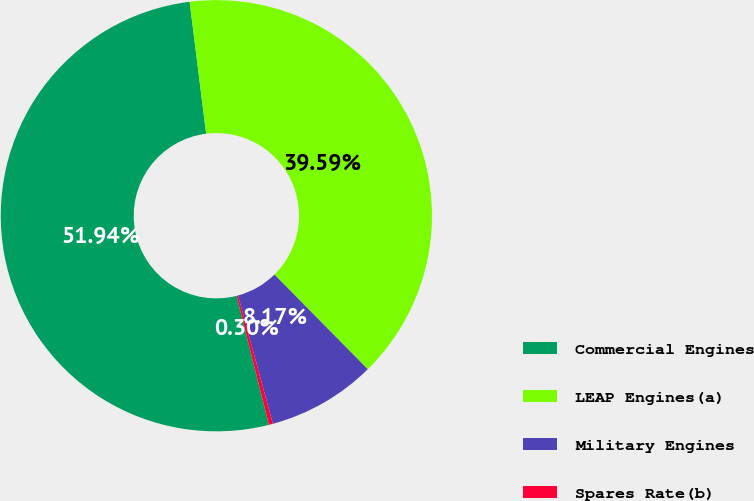Convert chart to OTSL. <chart><loc_0><loc_0><loc_500><loc_500><pie_chart><fcel>Commercial Engines<fcel>LEAP Engines(a)<fcel>Military Engines<fcel>Spares Rate(b)<nl><fcel>51.94%<fcel>39.59%<fcel>8.17%<fcel>0.3%<nl></chart> 